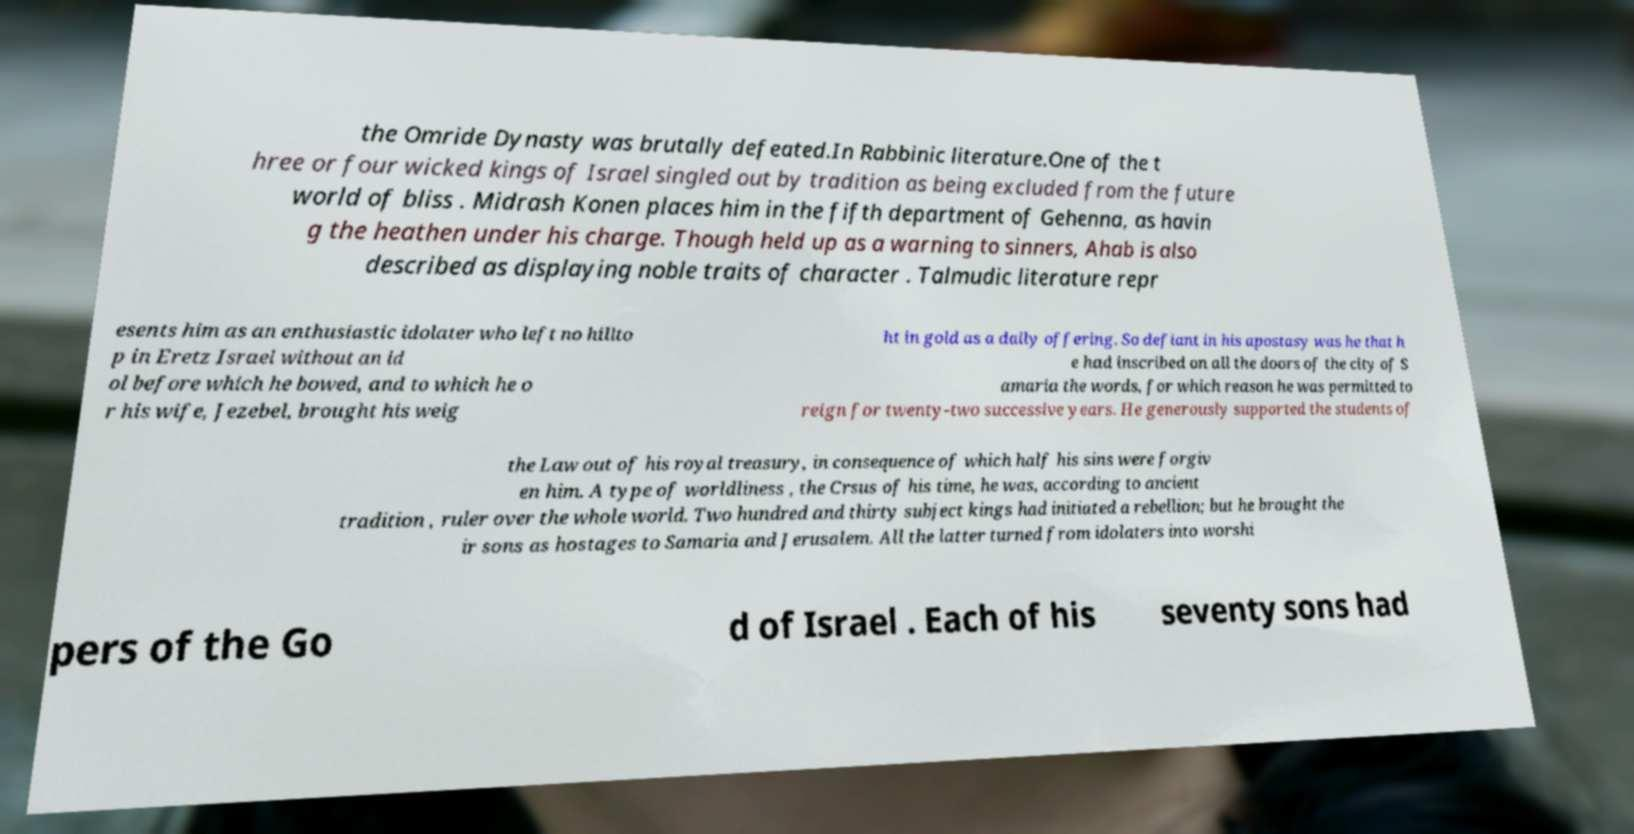Please identify and transcribe the text found in this image. the Omride Dynasty was brutally defeated.In Rabbinic literature.One of the t hree or four wicked kings of Israel singled out by tradition as being excluded from the future world of bliss . Midrash Konen places him in the fifth department of Gehenna, as havin g the heathen under his charge. Though held up as a warning to sinners, Ahab is also described as displaying noble traits of character . Talmudic literature repr esents him as an enthusiastic idolater who left no hillto p in Eretz Israel without an id ol before which he bowed, and to which he o r his wife, Jezebel, brought his weig ht in gold as a daily offering. So defiant in his apostasy was he that h e had inscribed on all the doors of the city of S amaria the words, for which reason he was permitted to reign for twenty-two successive years. He generously supported the students of the Law out of his royal treasury, in consequence of which half his sins were forgiv en him. A type of worldliness , the Crsus of his time, he was, according to ancient tradition , ruler over the whole world. Two hundred and thirty subject kings had initiated a rebellion; but he brought the ir sons as hostages to Samaria and Jerusalem. All the latter turned from idolaters into worshi pers of the Go d of Israel . Each of his seventy sons had 